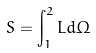<formula> <loc_0><loc_0><loc_500><loc_500>S = \int _ { 1 } ^ { 2 } L d \Omega</formula> 